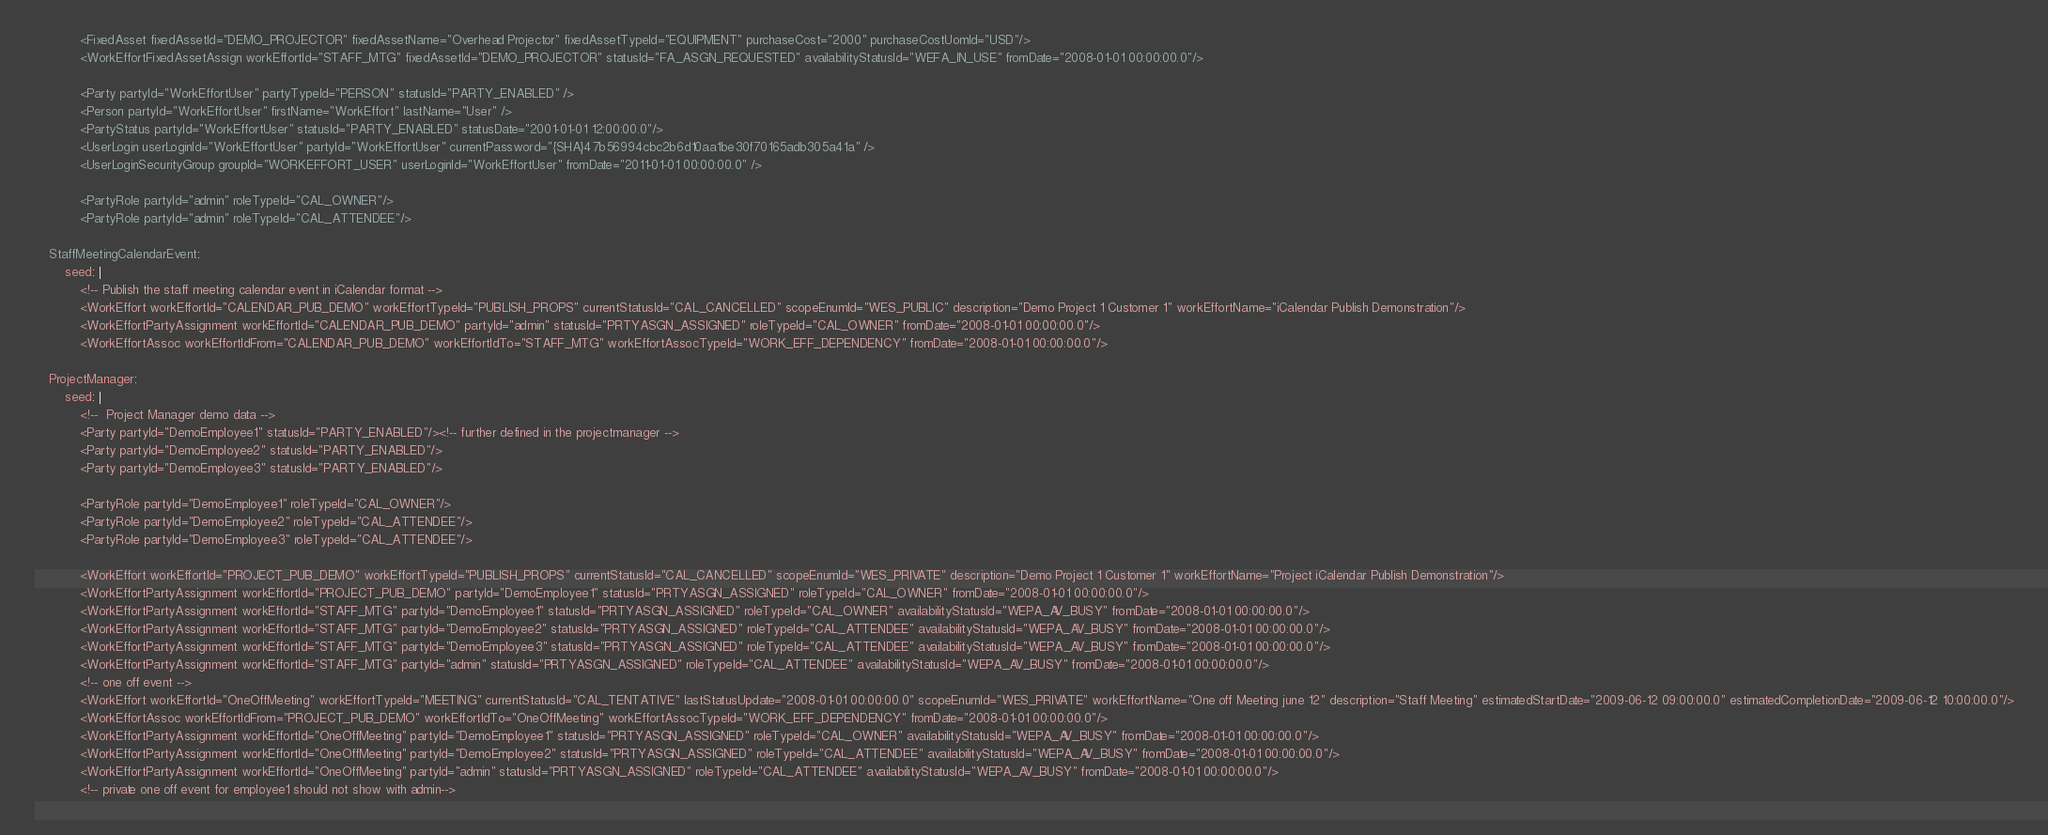Convert code to text. <code><loc_0><loc_0><loc_500><loc_500><_YAML_>            <FixedAsset fixedAssetId="DEMO_PROJECTOR" fixedAssetName="Overhead Projector" fixedAssetTypeId="EQUIPMENT" purchaseCost="2000" purchaseCostUomId="USD"/>
            <WorkEffortFixedAssetAssign workEffortId="STAFF_MTG" fixedAssetId="DEMO_PROJECTOR" statusId="FA_ASGN_REQUESTED" availabilityStatusId="WEFA_IN_USE" fromDate="2008-01-01 00:00:00.0"/>

            <Party partyId="WorkEffortUser" partyTypeId="PERSON" statusId="PARTY_ENABLED" />
            <Person partyId="WorkEffortUser" firstName="WorkEffort" lastName="User" />
            <PartyStatus partyId="WorkEffortUser" statusId="PARTY_ENABLED" statusDate="2001-01-01 12:00:00.0"/>
            <UserLogin userLoginId="WorkEffortUser" partyId="WorkEffortUser" currentPassword="{SHA}47b56994cbc2b6d10aa1be30f70165adb305a41a" />
            <UserLoginSecurityGroup groupId="WORKEFFORT_USER" userLoginId="WorkEffortUser" fromDate="2011-01-01 00:00:00.0" />

            <PartyRole partyId="admin" roleTypeId="CAL_OWNER"/>
            <PartyRole partyId="admin" roleTypeId="CAL_ATTENDEE"/>

    StaffMeetingCalendarEvent:
        seed: |
            <!-- Publish the staff meeting calendar event in iCalendar format -->
            <WorkEffort workEffortId="CALENDAR_PUB_DEMO" workEffortTypeId="PUBLISH_PROPS" currentStatusId="CAL_CANCELLED" scopeEnumId="WES_PUBLIC" description="Demo Project 1 Customer 1" workEffortName="iCalendar Publish Demonstration"/>
            <WorkEffortPartyAssignment workEffortId="CALENDAR_PUB_DEMO" partyId="admin" statusId="PRTYASGN_ASSIGNED" roleTypeId="CAL_OWNER" fromDate="2008-01-01 00:00:00.0"/>
            <WorkEffortAssoc workEffortIdFrom="CALENDAR_PUB_DEMO" workEffortIdTo="STAFF_MTG" workEffortAssocTypeId="WORK_EFF_DEPENDENCY" fromDate="2008-01-01 00:00:00.0"/>

    ProjectManager:
        seed: |
            <!--  Project Manager demo data -->
            <Party partyId="DemoEmployee1" statusId="PARTY_ENABLED"/><!-- further defined in the projectmanager -->
            <Party partyId="DemoEmployee2" statusId="PARTY_ENABLED"/>
            <Party partyId="DemoEmployee3" statusId="PARTY_ENABLED"/>

            <PartyRole partyId="DemoEmployee1" roleTypeId="CAL_OWNER"/>
            <PartyRole partyId="DemoEmployee2" roleTypeId="CAL_ATTENDEE"/>
            <PartyRole partyId="DemoEmployee3" roleTypeId="CAL_ATTENDEE"/>

            <WorkEffort workEffortId="PROJECT_PUB_DEMO" workEffortTypeId="PUBLISH_PROPS" currentStatusId="CAL_CANCELLED" scopeEnumId="WES_PRIVATE" description="Demo Project 1 Customer 1" workEffortName="Project iCalendar Publish Demonstration"/>
            <WorkEffortPartyAssignment workEffortId="PROJECT_PUB_DEMO" partyId="DemoEmployee1" statusId="PRTYASGN_ASSIGNED" roleTypeId="CAL_OWNER" fromDate="2008-01-01 00:00:00.0"/>
            <WorkEffortPartyAssignment workEffortId="STAFF_MTG" partyId="DemoEmployee1" statusId="PRTYASGN_ASSIGNED" roleTypeId="CAL_OWNER" availabilityStatusId="WEPA_AV_BUSY" fromDate="2008-01-01 00:00:00.0"/>
            <WorkEffortPartyAssignment workEffortId="STAFF_MTG" partyId="DemoEmployee2" statusId="PRTYASGN_ASSIGNED" roleTypeId="CAL_ATTENDEE" availabilityStatusId="WEPA_AV_BUSY" fromDate="2008-01-01 00:00:00.0"/>
            <WorkEffortPartyAssignment workEffortId="STAFF_MTG" partyId="DemoEmployee3" statusId="PRTYASGN_ASSIGNED" roleTypeId="CAL_ATTENDEE" availabilityStatusId="WEPA_AV_BUSY" fromDate="2008-01-01 00:00:00.0"/>
            <WorkEffortPartyAssignment workEffortId="STAFF_MTG" partyId="admin" statusId="PRTYASGN_ASSIGNED" roleTypeId="CAL_ATTENDEE" availabilityStatusId="WEPA_AV_BUSY" fromDate="2008-01-01 00:00:00.0"/>
            <!-- one off event -->
            <WorkEffort workEffortId="OneOffMeeting" workEffortTypeId="MEETING" currentStatusId="CAL_TENTATIVE" lastStatusUpdate="2008-01-01 00:00:00.0" scopeEnumId="WES_PRIVATE" workEffortName="One off Meeting june 12" description="Staff Meeting" estimatedStartDate="2009-06-12 09:00:00.0" estimatedCompletionDate="2009-06-12 10:00:00.0"/>
            <WorkEffortAssoc workEffortIdFrom="PROJECT_PUB_DEMO" workEffortIdTo="OneOffMeeting" workEffortAssocTypeId="WORK_EFF_DEPENDENCY" fromDate="2008-01-01 00:00:00.0"/>
            <WorkEffortPartyAssignment workEffortId="OneOffMeeting" partyId="DemoEmployee1" statusId="PRTYASGN_ASSIGNED" roleTypeId="CAL_OWNER" availabilityStatusId="WEPA_AV_BUSY" fromDate="2008-01-01 00:00:00.0"/>
            <WorkEffortPartyAssignment workEffortId="OneOffMeeting" partyId="DemoEmployee2" statusId="PRTYASGN_ASSIGNED" roleTypeId="CAL_ATTENDEE" availabilityStatusId="WEPA_AV_BUSY" fromDate="2008-01-01 00:00:00.0"/>
            <WorkEffortPartyAssignment workEffortId="OneOffMeeting" partyId="admin" statusId="PRTYASGN_ASSIGNED" roleTypeId="CAL_ATTENDEE" availabilityStatusId="WEPA_AV_BUSY" fromDate="2008-01-01 00:00:00.0"/>
            <!-- private one off event for employee1 should not show with admin--></code> 